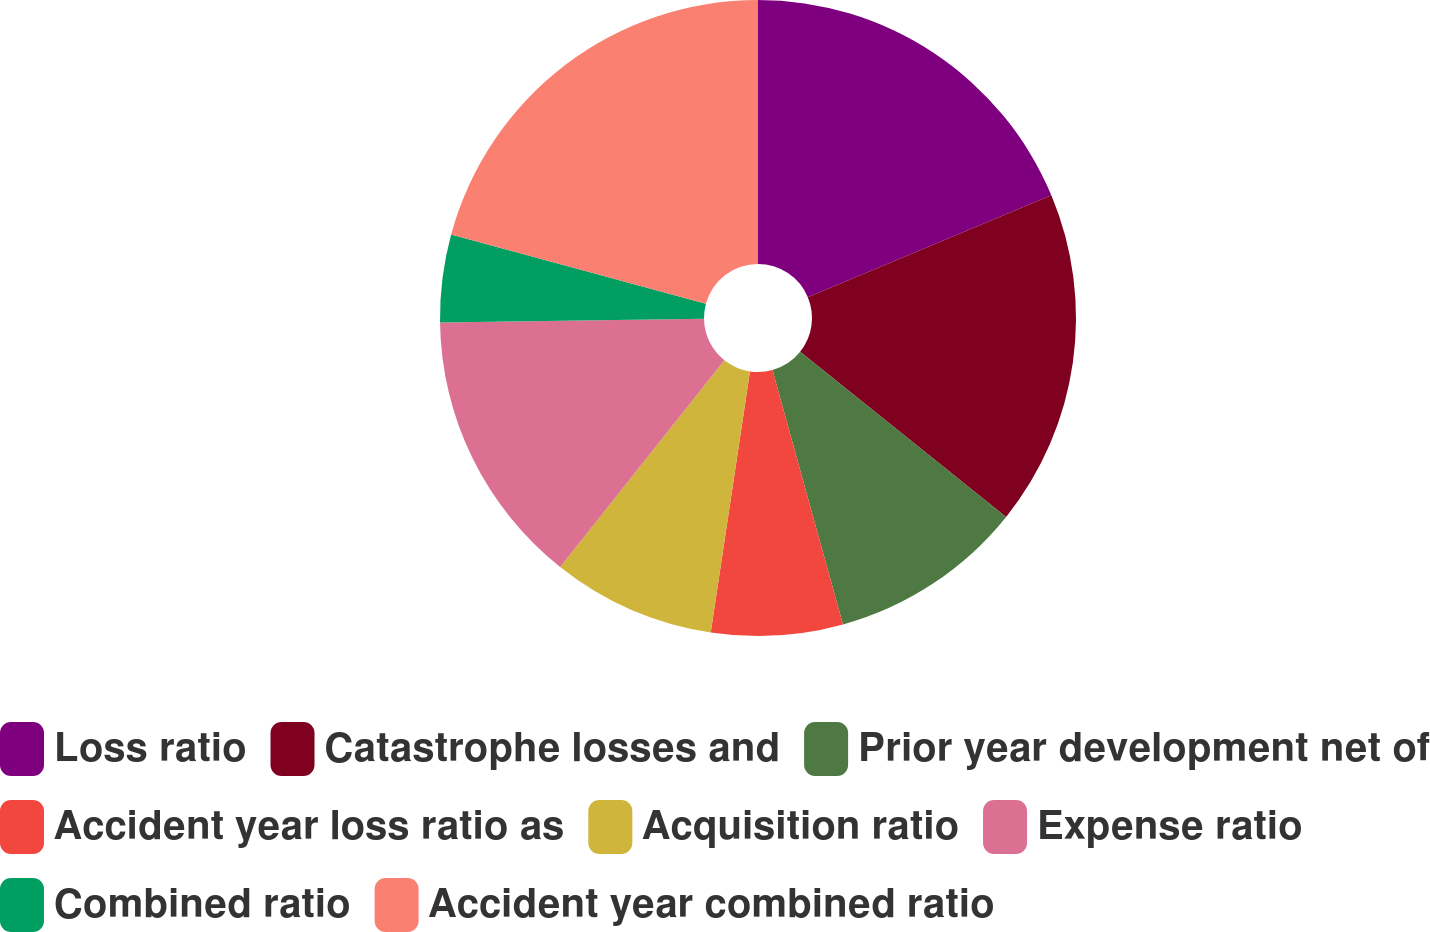Convert chart to OTSL. <chart><loc_0><loc_0><loc_500><loc_500><pie_chart><fcel>Loss ratio<fcel>Catastrophe losses and<fcel>Prior year development net of<fcel>Accident year loss ratio as<fcel>Acquisition ratio<fcel>Expense ratio<fcel>Combined ratio<fcel>Accident year combined ratio<nl><fcel>18.69%<fcel>17.06%<fcel>9.94%<fcel>6.68%<fcel>8.31%<fcel>14.09%<fcel>4.45%<fcel>20.77%<nl></chart> 